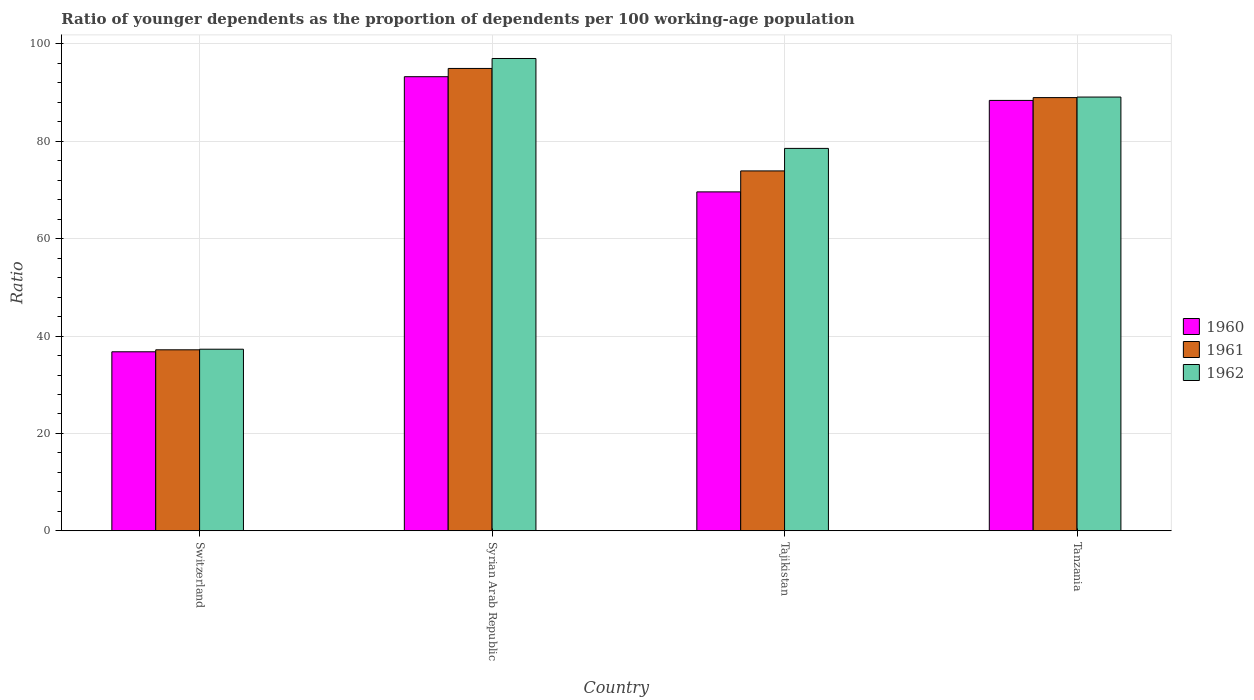How many different coloured bars are there?
Your answer should be compact. 3. How many groups of bars are there?
Keep it short and to the point. 4. Are the number of bars per tick equal to the number of legend labels?
Your answer should be compact. Yes. How many bars are there on the 1st tick from the left?
Make the answer very short. 3. How many bars are there on the 4th tick from the right?
Offer a very short reply. 3. What is the label of the 4th group of bars from the left?
Offer a terse response. Tanzania. In how many cases, is the number of bars for a given country not equal to the number of legend labels?
Provide a short and direct response. 0. What is the age dependency ratio(young) in 1960 in Tajikistan?
Provide a short and direct response. 69.62. Across all countries, what is the maximum age dependency ratio(young) in 1962?
Your answer should be compact. 97.02. Across all countries, what is the minimum age dependency ratio(young) in 1960?
Your response must be concise. 36.77. In which country was the age dependency ratio(young) in 1962 maximum?
Your response must be concise. Syrian Arab Republic. In which country was the age dependency ratio(young) in 1962 minimum?
Your answer should be compact. Switzerland. What is the total age dependency ratio(young) in 1962 in the graph?
Your response must be concise. 301.95. What is the difference between the age dependency ratio(young) in 1962 in Switzerland and that in Syrian Arab Republic?
Offer a terse response. -59.72. What is the difference between the age dependency ratio(young) in 1962 in Tajikistan and the age dependency ratio(young) in 1960 in Tanzania?
Your response must be concise. -9.86. What is the average age dependency ratio(young) in 1961 per country?
Make the answer very short. 73.76. What is the difference between the age dependency ratio(young) of/in 1960 and age dependency ratio(young) of/in 1962 in Tajikistan?
Provide a short and direct response. -8.93. In how many countries, is the age dependency ratio(young) in 1960 greater than 8?
Give a very brief answer. 4. What is the ratio of the age dependency ratio(young) in 1961 in Switzerland to that in Syrian Arab Republic?
Give a very brief answer. 0.39. Is the age dependency ratio(young) in 1962 in Tajikistan less than that in Tanzania?
Your answer should be very brief. Yes. Is the difference between the age dependency ratio(young) in 1960 in Switzerland and Tanzania greater than the difference between the age dependency ratio(young) in 1962 in Switzerland and Tanzania?
Your answer should be very brief. Yes. What is the difference between the highest and the second highest age dependency ratio(young) in 1961?
Give a very brief answer. 15.06. What is the difference between the highest and the lowest age dependency ratio(young) in 1960?
Make the answer very short. 56.51. Is it the case that in every country, the sum of the age dependency ratio(young) in 1962 and age dependency ratio(young) in 1961 is greater than the age dependency ratio(young) in 1960?
Ensure brevity in your answer.  Yes. How many bars are there?
Make the answer very short. 12. What is the difference between two consecutive major ticks on the Y-axis?
Provide a short and direct response. 20. Does the graph contain grids?
Offer a very short reply. Yes. How many legend labels are there?
Offer a terse response. 3. What is the title of the graph?
Provide a succinct answer. Ratio of younger dependents as the proportion of dependents per 100 working-age population. Does "1994" appear as one of the legend labels in the graph?
Make the answer very short. No. What is the label or title of the X-axis?
Offer a terse response. Country. What is the label or title of the Y-axis?
Make the answer very short. Ratio. What is the Ratio of 1960 in Switzerland?
Your answer should be compact. 36.77. What is the Ratio in 1961 in Switzerland?
Offer a terse response. 37.18. What is the Ratio in 1962 in Switzerland?
Offer a terse response. 37.3. What is the Ratio of 1960 in Syrian Arab Republic?
Offer a very short reply. 93.28. What is the Ratio of 1961 in Syrian Arab Republic?
Give a very brief answer. 94.97. What is the Ratio of 1962 in Syrian Arab Republic?
Provide a succinct answer. 97.02. What is the Ratio in 1960 in Tajikistan?
Offer a very short reply. 69.62. What is the Ratio in 1961 in Tajikistan?
Make the answer very short. 73.92. What is the Ratio in 1962 in Tajikistan?
Keep it short and to the point. 78.55. What is the Ratio in 1960 in Tanzania?
Your answer should be very brief. 88.41. What is the Ratio in 1961 in Tanzania?
Offer a very short reply. 88.98. What is the Ratio of 1962 in Tanzania?
Your answer should be very brief. 89.09. Across all countries, what is the maximum Ratio in 1960?
Keep it short and to the point. 93.28. Across all countries, what is the maximum Ratio of 1961?
Give a very brief answer. 94.97. Across all countries, what is the maximum Ratio of 1962?
Offer a terse response. 97.02. Across all countries, what is the minimum Ratio in 1960?
Provide a short and direct response. 36.77. Across all countries, what is the minimum Ratio of 1961?
Your response must be concise. 37.18. Across all countries, what is the minimum Ratio of 1962?
Keep it short and to the point. 37.3. What is the total Ratio in 1960 in the graph?
Ensure brevity in your answer.  288.07. What is the total Ratio in 1961 in the graph?
Your response must be concise. 295.05. What is the total Ratio of 1962 in the graph?
Offer a terse response. 301.95. What is the difference between the Ratio of 1960 in Switzerland and that in Syrian Arab Republic?
Make the answer very short. -56.51. What is the difference between the Ratio of 1961 in Switzerland and that in Syrian Arab Republic?
Provide a short and direct response. -57.8. What is the difference between the Ratio of 1962 in Switzerland and that in Syrian Arab Republic?
Make the answer very short. -59.72. What is the difference between the Ratio of 1960 in Switzerland and that in Tajikistan?
Offer a terse response. -32.85. What is the difference between the Ratio of 1961 in Switzerland and that in Tajikistan?
Your answer should be very brief. -36.75. What is the difference between the Ratio in 1962 in Switzerland and that in Tajikistan?
Your response must be concise. -41.25. What is the difference between the Ratio in 1960 in Switzerland and that in Tanzania?
Your answer should be compact. -51.64. What is the difference between the Ratio of 1961 in Switzerland and that in Tanzania?
Offer a very short reply. -51.81. What is the difference between the Ratio in 1962 in Switzerland and that in Tanzania?
Your response must be concise. -51.8. What is the difference between the Ratio of 1960 in Syrian Arab Republic and that in Tajikistan?
Your answer should be very brief. 23.66. What is the difference between the Ratio of 1961 in Syrian Arab Republic and that in Tajikistan?
Provide a short and direct response. 21.05. What is the difference between the Ratio in 1962 in Syrian Arab Republic and that in Tajikistan?
Provide a short and direct response. 18.47. What is the difference between the Ratio of 1960 in Syrian Arab Republic and that in Tanzania?
Make the answer very short. 4.87. What is the difference between the Ratio of 1961 in Syrian Arab Republic and that in Tanzania?
Keep it short and to the point. 5.99. What is the difference between the Ratio of 1962 in Syrian Arab Republic and that in Tanzania?
Your answer should be compact. 7.92. What is the difference between the Ratio in 1960 in Tajikistan and that in Tanzania?
Your response must be concise. -18.79. What is the difference between the Ratio of 1961 in Tajikistan and that in Tanzania?
Your answer should be compact. -15.06. What is the difference between the Ratio in 1962 in Tajikistan and that in Tanzania?
Provide a succinct answer. -10.55. What is the difference between the Ratio in 1960 in Switzerland and the Ratio in 1961 in Syrian Arab Republic?
Your answer should be compact. -58.2. What is the difference between the Ratio of 1960 in Switzerland and the Ratio of 1962 in Syrian Arab Republic?
Give a very brief answer. -60.25. What is the difference between the Ratio of 1961 in Switzerland and the Ratio of 1962 in Syrian Arab Republic?
Your response must be concise. -59.84. What is the difference between the Ratio of 1960 in Switzerland and the Ratio of 1961 in Tajikistan?
Offer a very short reply. -37.15. What is the difference between the Ratio in 1960 in Switzerland and the Ratio in 1962 in Tajikistan?
Your response must be concise. -41.78. What is the difference between the Ratio in 1961 in Switzerland and the Ratio in 1962 in Tajikistan?
Provide a succinct answer. -41.37. What is the difference between the Ratio of 1960 in Switzerland and the Ratio of 1961 in Tanzania?
Keep it short and to the point. -52.21. What is the difference between the Ratio in 1960 in Switzerland and the Ratio in 1962 in Tanzania?
Provide a short and direct response. -52.32. What is the difference between the Ratio in 1961 in Switzerland and the Ratio in 1962 in Tanzania?
Keep it short and to the point. -51.92. What is the difference between the Ratio of 1960 in Syrian Arab Republic and the Ratio of 1961 in Tajikistan?
Offer a terse response. 19.35. What is the difference between the Ratio of 1960 in Syrian Arab Republic and the Ratio of 1962 in Tajikistan?
Keep it short and to the point. 14.73. What is the difference between the Ratio of 1961 in Syrian Arab Republic and the Ratio of 1962 in Tajikistan?
Provide a succinct answer. 16.42. What is the difference between the Ratio of 1960 in Syrian Arab Republic and the Ratio of 1961 in Tanzania?
Give a very brief answer. 4.29. What is the difference between the Ratio of 1960 in Syrian Arab Republic and the Ratio of 1962 in Tanzania?
Ensure brevity in your answer.  4.18. What is the difference between the Ratio of 1961 in Syrian Arab Republic and the Ratio of 1962 in Tanzania?
Ensure brevity in your answer.  5.88. What is the difference between the Ratio of 1960 in Tajikistan and the Ratio of 1961 in Tanzania?
Make the answer very short. -19.37. What is the difference between the Ratio in 1960 in Tajikistan and the Ratio in 1962 in Tanzania?
Your response must be concise. -19.48. What is the difference between the Ratio in 1961 in Tajikistan and the Ratio in 1962 in Tanzania?
Your answer should be very brief. -15.17. What is the average Ratio in 1960 per country?
Your answer should be compact. 72.02. What is the average Ratio in 1961 per country?
Give a very brief answer. 73.76. What is the average Ratio of 1962 per country?
Make the answer very short. 75.49. What is the difference between the Ratio in 1960 and Ratio in 1961 in Switzerland?
Your response must be concise. -0.41. What is the difference between the Ratio in 1960 and Ratio in 1962 in Switzerland?
Offer a terse response. -0.53. What is the difference between the Ratio in 1961 and Ratio in 1962 in Switzerland?
Your response must be concise. -0.12. What is the difference between the Ratio in 1960 and Ratio in 1961 in Syrian Arab Republic?
Make the answer very short. -1.69. What is the difference between the Ratio in 1960 and Ratio in 1962 in Syrian Arab Republic?
Your response must be concise. -3.74. What is the difference between the Ratio of 1961 and Ratio of 1962 in Syrian Arab Republic?
Keep it short and to the point. -2.05. What is the difference between the Ratio in 1960 and Ratio in 1961 in Tajikistan?
Offer a very short reply. -4.31. What is the difference between the Ratio in 1960 and Ratio in 1962 in Tajikistan?
Keep it short and to the point. -8.93. What is the difference between the Ratio of 1961 and Ratio of 1962 in Tajikistan?
Ensure brevity in your answer.  -4.62. What is the difference between the Ratio in 1960 and Ratio in 1961 in Tanzania?
Keep it short and to the point. -0.58. What is the difference between the Ratio in 1960 and Ratio in 1962 in Tanzania?
Your response must be concise. -0.69. What is the difference between the Ratio of 1961 and Ratio of 1962 in Tanzania?
Provide a short and direct response. -0.11. What is the ratio of the Ratio of 1960 in Switzerland to that in Syrian Arab Republic?
Your response must be concise. 0.39. What is the ratio of the Ratio in 1961 in Switzerland to that in Syrian Arab Republic?
Offer a very short reply. 0.39. What is the ratio of the Ratio in 1962 in Switzerland to that in Syrian Arab Republic?
Ensure brevity in your answer.  0.38. What is the ratio of the Ratio in 1960 in Switzerland to that in Tajikistan?
Make the answer very short. 0.53. What is the ratio of the Ratio of 1961 in Switzerland to that in Tajikistan?
Your answer should be compact. 0.5. What is the ratio of the Ratio in 1962 in Switzerland to that in Tajikistan?
Keep it short and to the point. 0.47. What is the ratio of the Ratio in 1960 in Switzerland to that in Tanzania?
Ensure brevity in your answer.  0.42. What is the ratio of the Ratio in 1961 in Switzerland to that in Tanzania?
Offer a very short reply. 0.42. What is the ratio of the Ratio in 1962 in Switzerland to that in Tanzania?
Offer a terse response. 0.42. What is the ratio of the Ratio in 1960 in Syrian Arab Republic to that in Tajikistan?
Make the answer very short. 1.34. What is the ratio of the Ratio in 1961 in Syrian Arab Republic to that in Tajikistan?
Your answer should be very brief. 1.28. What is the ratio of the Ratio in 1962 in Syrian Arab Republic to that in Tajikistan?
Your response must be concise. 1.24. What is the ratio of the Ratio in 1960 in Syrian Arab Republic to that in Tanzania?
Offer a very short reply. 1.06. What is the ratio of the Ratio of 1961 in Syrian Arab Republic to that in Tanzania?
Offer a terse response. 1.07. What is the ratio of the Ratio in 1962 in Syrian Arab Republic to that in Tanzania?
Give a very brief answer. 1.09. What is the ratio of the Ratio of 1960 in Tajikistan to that in Tanzania?
Provide a succinct answer. 0.79. What is the ratio of the Ratio of 1961 in Tajikistan to that in Tanzania?
Offer a terse response. 0.83. What is the ratio of the Ratio of 1962 in Tajikistan to that in Tanzania?
Give a very brief answer. 0.88. What is the difference between the highest and the second highest Ratio of 1960?
Offer a terse response. 4.87. What is the difference between the highest and the second highest Ratio in 1961?
Provide a short and direct response. 5.99. What is the difference between the highest and the second highest Ratio in 1962?
Your answer should be compact. 7.92. What is the difference between the highest and the lowest Ratio in 1960?
Offer a very short reply. 56.51. What is the difference between the highest and the lowest Ratio of 1961?
Ensure brevity in your answer.  57.8. What is the difference between the highest and the lowest Ratio of 1962?
Provide a succinct answer. 59.72. 